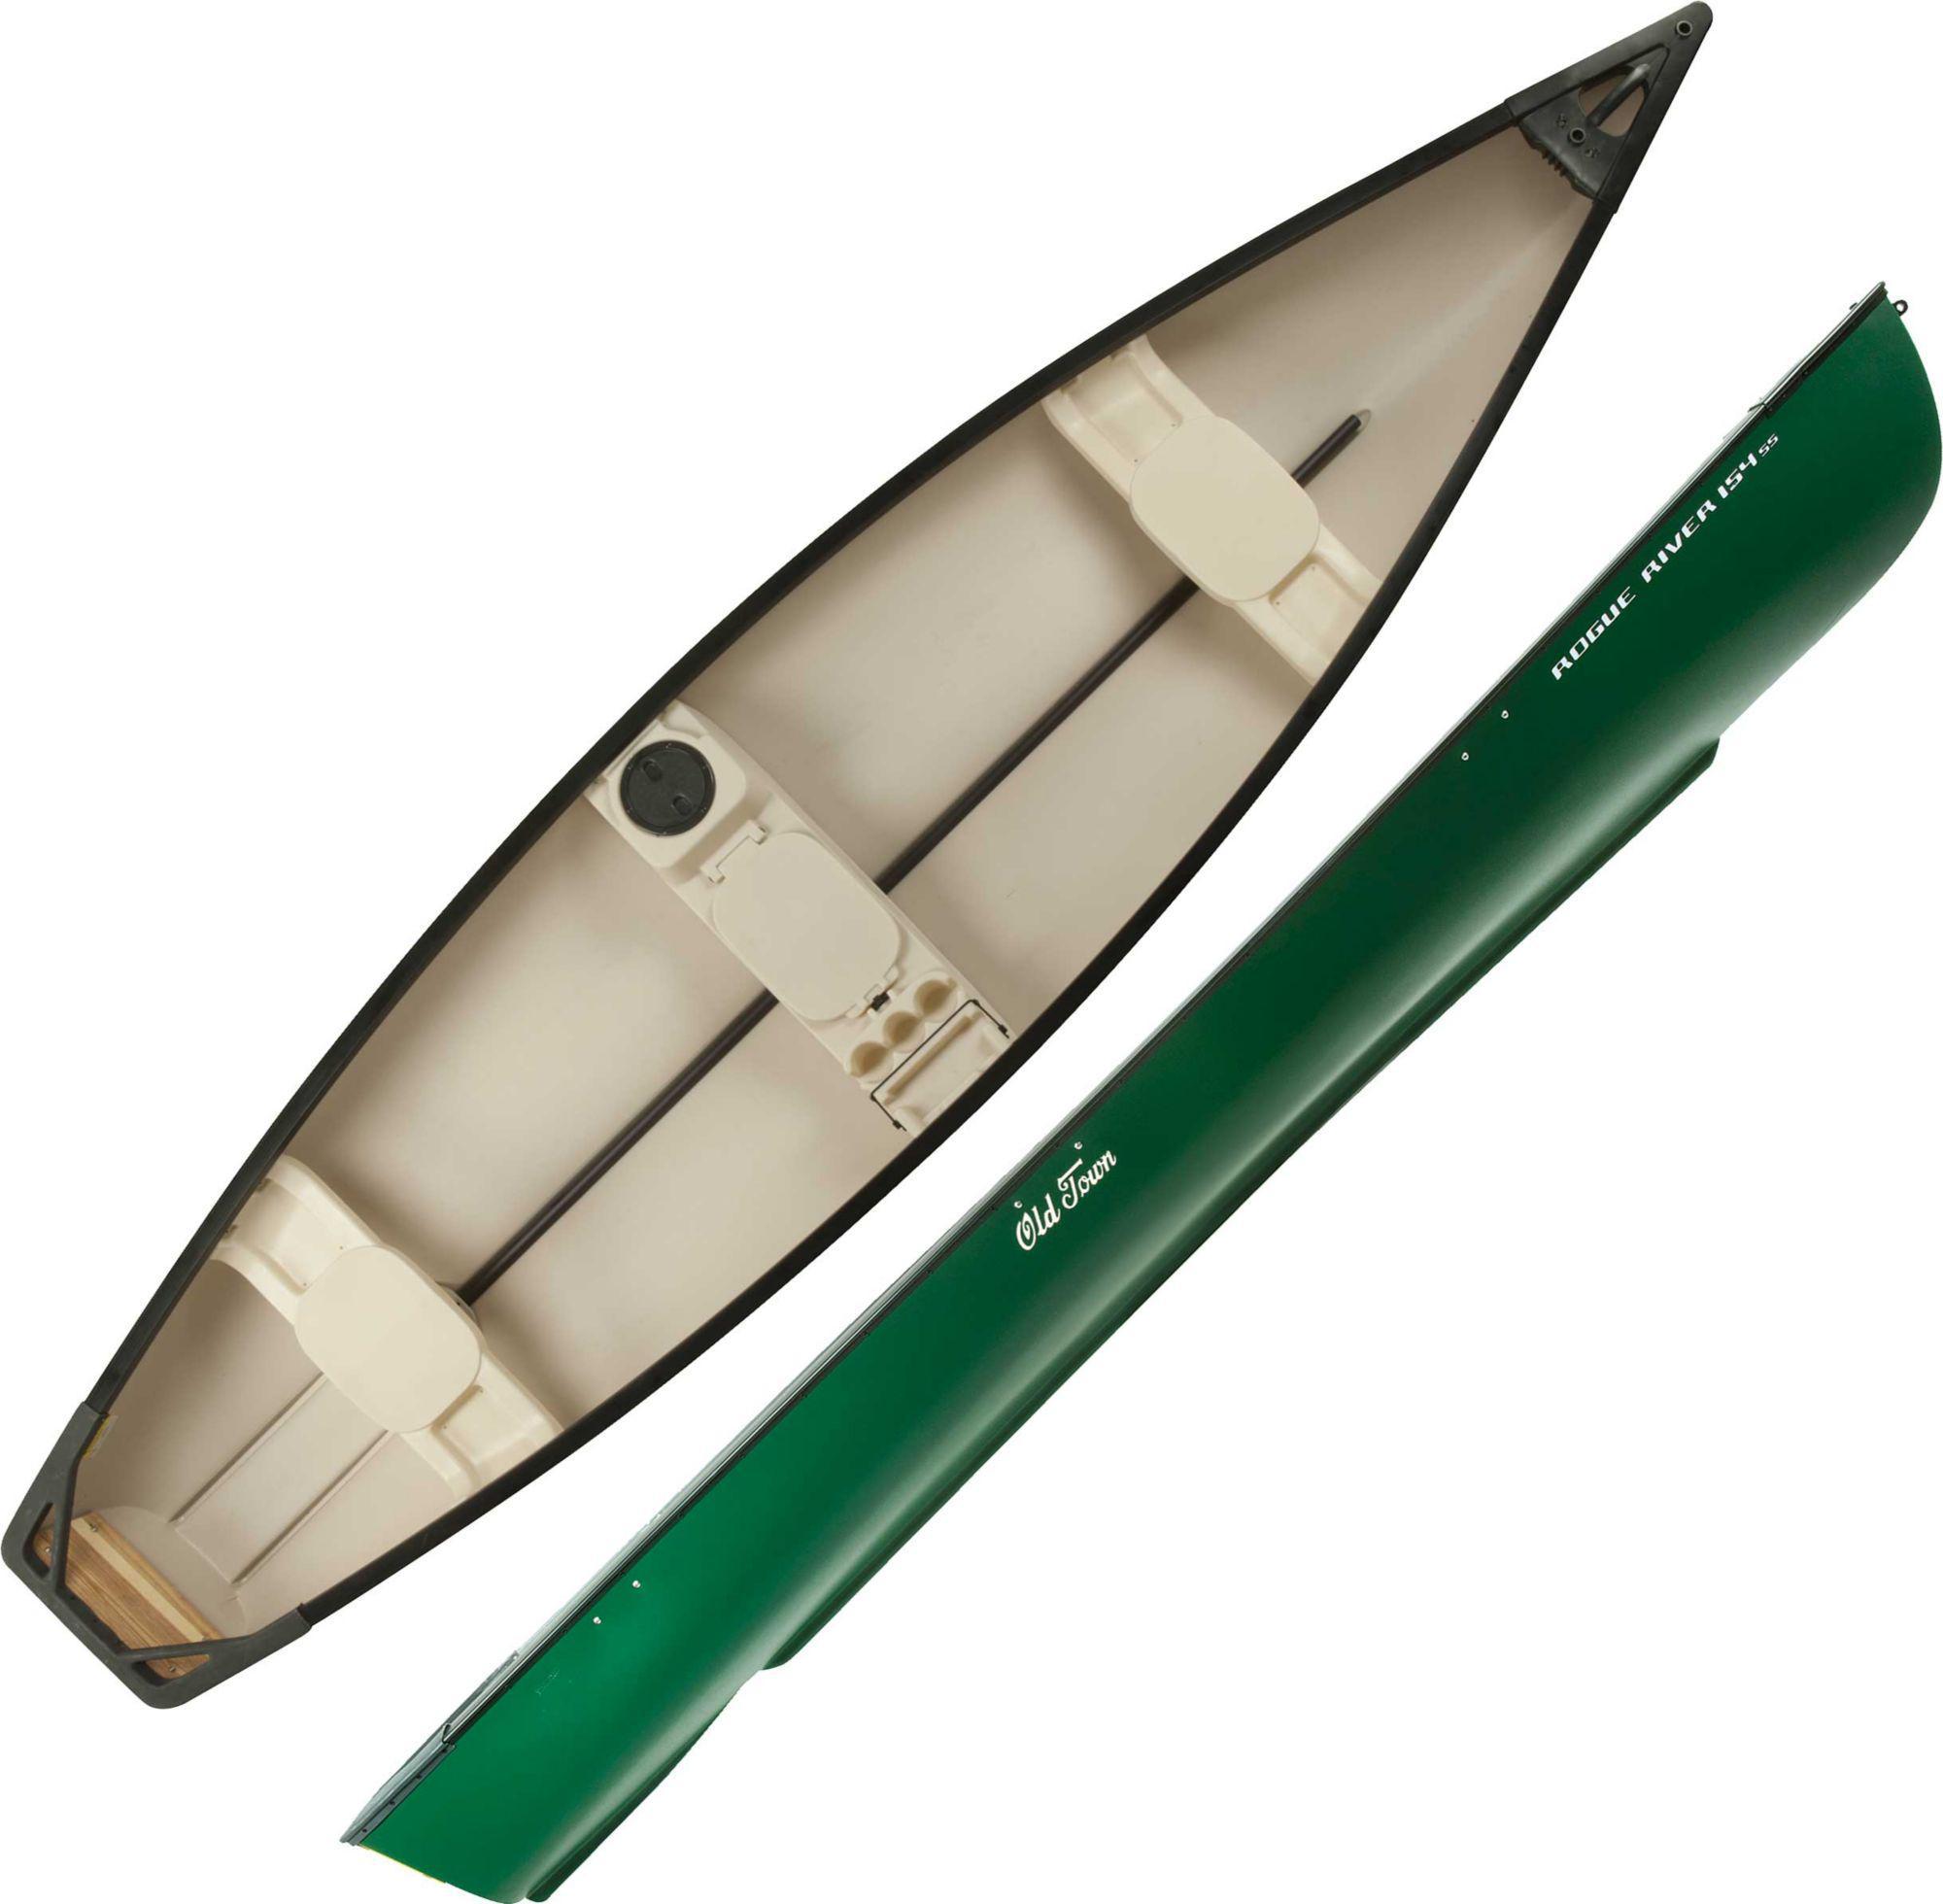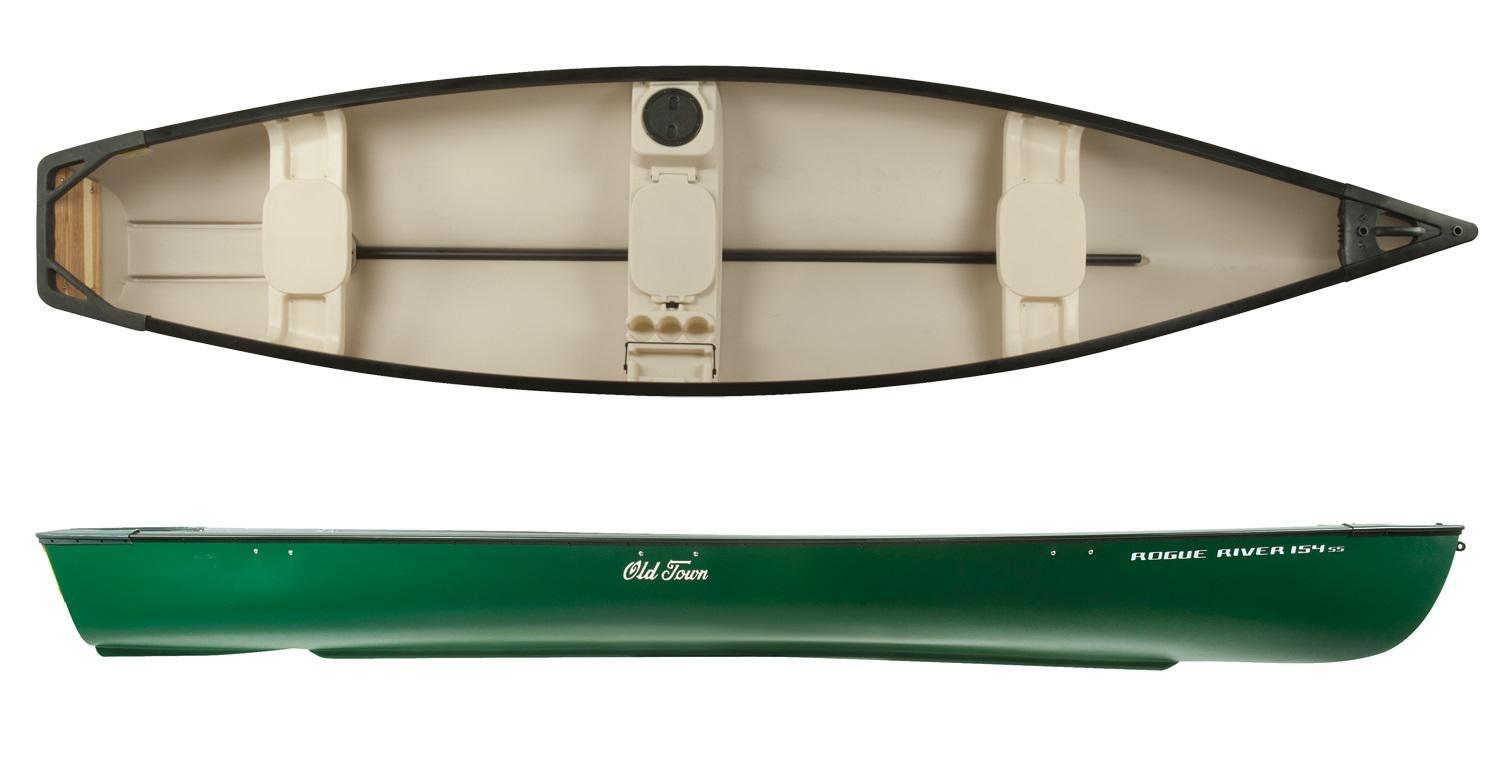The first image is the image on the left, the second image is the image on the right. Assess this claim about the two images: "At least one image shows a boat displayed horizontally in both side and aerial views.". Correct or not? Answer yes or no. Yes. The first image is the image on the left, the second image is the image on the right. Evaluate the accuracy of this statement regarding the images: "Both images show top and side angles of a green boat.". Is it true? Answer yes or no. Yes. 